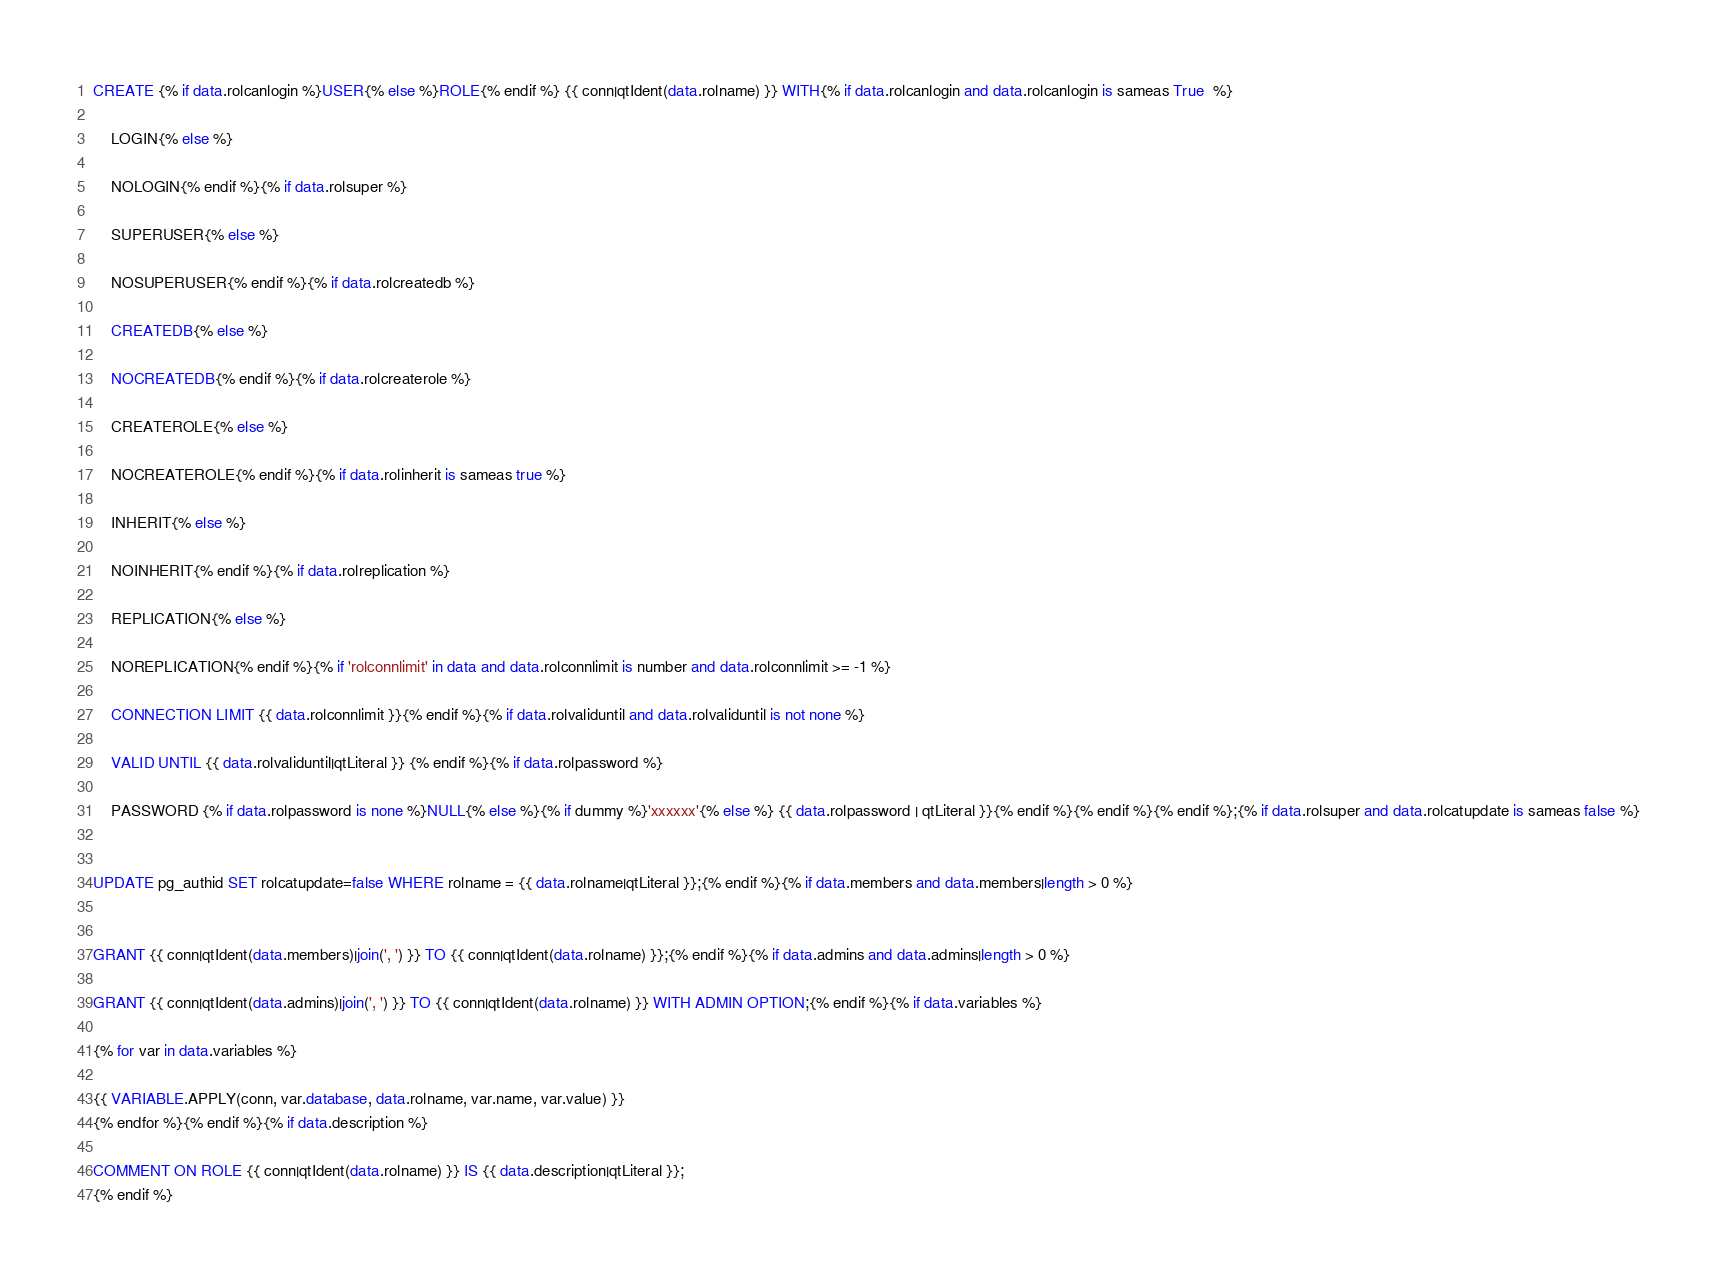<code> <loc_0><loc_0><loc_500><loc_500><_SQL_>CREATE {% if data.rolcanlogin %}USER{% else %}ROLE{% endif %} {{ conn|qtIdent(data.rolname) }} WITH{% if data.rolcanlogin and data.rolcanlogin is sameas True  %}

	LOGIN{% else %}

	NOLOGIN{% endif %}{% if data.rolsuper %}

	SUPERUSER{% else %}

	NOSUPERUSER{% endif %}{% if data.rolcreatedb %}

	CREATEDB{% else %}

	NOCREATEDB{% endif %}{% if data.rolcreaterole %}

	CREATEROLE{% else %}

	NOCREATEROLE{% endif %}{% if data.rolinherit is sameas true %}

	INHERIT{% else %}

	NOINHERIT{% endif %}{% if data.rolreplication %}

	REPLICATION{% else %}

	NOREPLICATION{% endif %}{% if 'rolconnlimit' in data and data.rolconnlimit is number and data.rolconnlimit >= -1 %}

	CONNECTION LIMIT {{ data.rolconnlimit }}{% endif %}{% if data.rolvaliduntil and data.rolvaliduntil is not none %}

	VALID UNTIL {{ data.rolvaliduntil|qtLiteral }} {% endif %}{% if data.rolpassword %}

	PASSWORD {% if data.rolpassword is none %}NULL{% else %}{% if dummy %}'xxxxxx'{% else %} {{ data.rolpassword | qtLiteral }}{% endif %}{% endif %}{% endif %};{% if data.rolsuper and data.rolcatupdate is sameas false %}


UPDATE pg_authid SET rolcatupdate=false WHERE rolname = {{ data.rolname|qtLiteral }};{% endif %}{% if data.members and data.members|length > 0 %}


GRANT {{ conn|qtIdent(data.members)|join(', ') }} TO {{ conn|qtIdent(data.rolname) }};{% endif %}{% if data.admins and data.admins|length > 0 %}

GRANT {{ conn|qtIdent(data.admins)|join(', ') }} TO {{ conn|qtIdent(data.rolname) }} WITH ADMIN OPTION;{% endif %}{% if data.variables %}

{% for var in data.variables %}

{{ VARIABLE.APPLY(conn, var.database, data.rolname, var.name, var.value) }}
{% endfor %}{% endif %}{% if data.description %}

COMMENT ON ROLE {{ conn|qtIdent(data.rolname) }} IS {{ data.description|qtLiteral }};
{% endif %}
</code> 